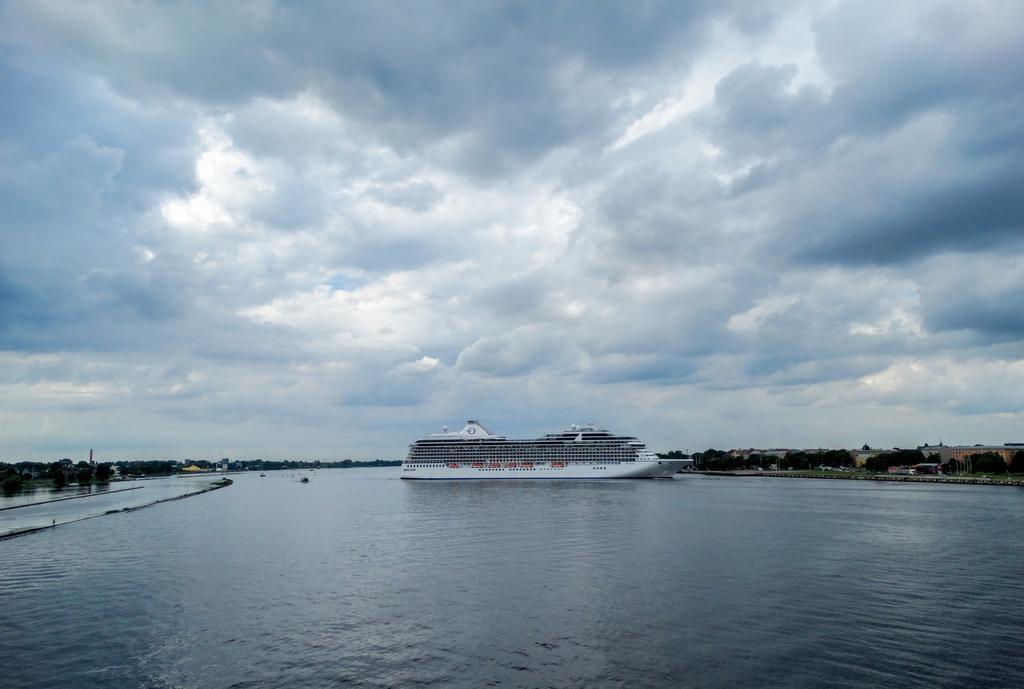Describe this image in one or two sentences. In this image I can see the water surface. I can see a ship on the water surface. I can see few trees. At the top I can see some clouds in the sky. 